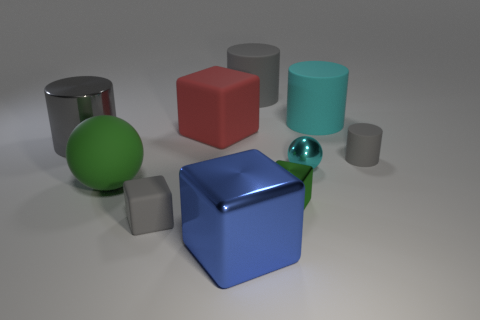How many objects are small things to the right of the large cyan cylinder or shiny objects behind the big green rubber object?
Offer a terse response. 3. Do the cyan cylinder to the right of the large red rubber object and the matte thing that is in front of the large sphere have the same size?
Make the answer very short. No. The other large object that is the same shape as the cyan metal thing is what color?
Provide a short and direct response. Green. Is there any other thing that is the same shape as the tiny cyan shiny thing?
Offer a very short reply. Yes. Are there more big metal cylinders to the left of the tiny cyan metal ball than large red matte blocks that are behind the big gray rubber object?
Your response must be concise. Yes. There is a cube behind the ball on the right side of the matte cube that is in front of the big rubber block; how big is it?
Offer a very short reply. Large. Are the large green object and the big gray thing that is behind the red cube made of the same material?
Make the answer very short. Yes. Is the shape of the gray shiny thing the same as the big cyan rubber object?
Provide a succinct answer. Yes. How many other objects are the same material as the big cyan cylinder?
Ensure brevity in your answer.  5. How many metallic objects have the same shape as the cyan matte object?
Keep it short and to the point. 1. 